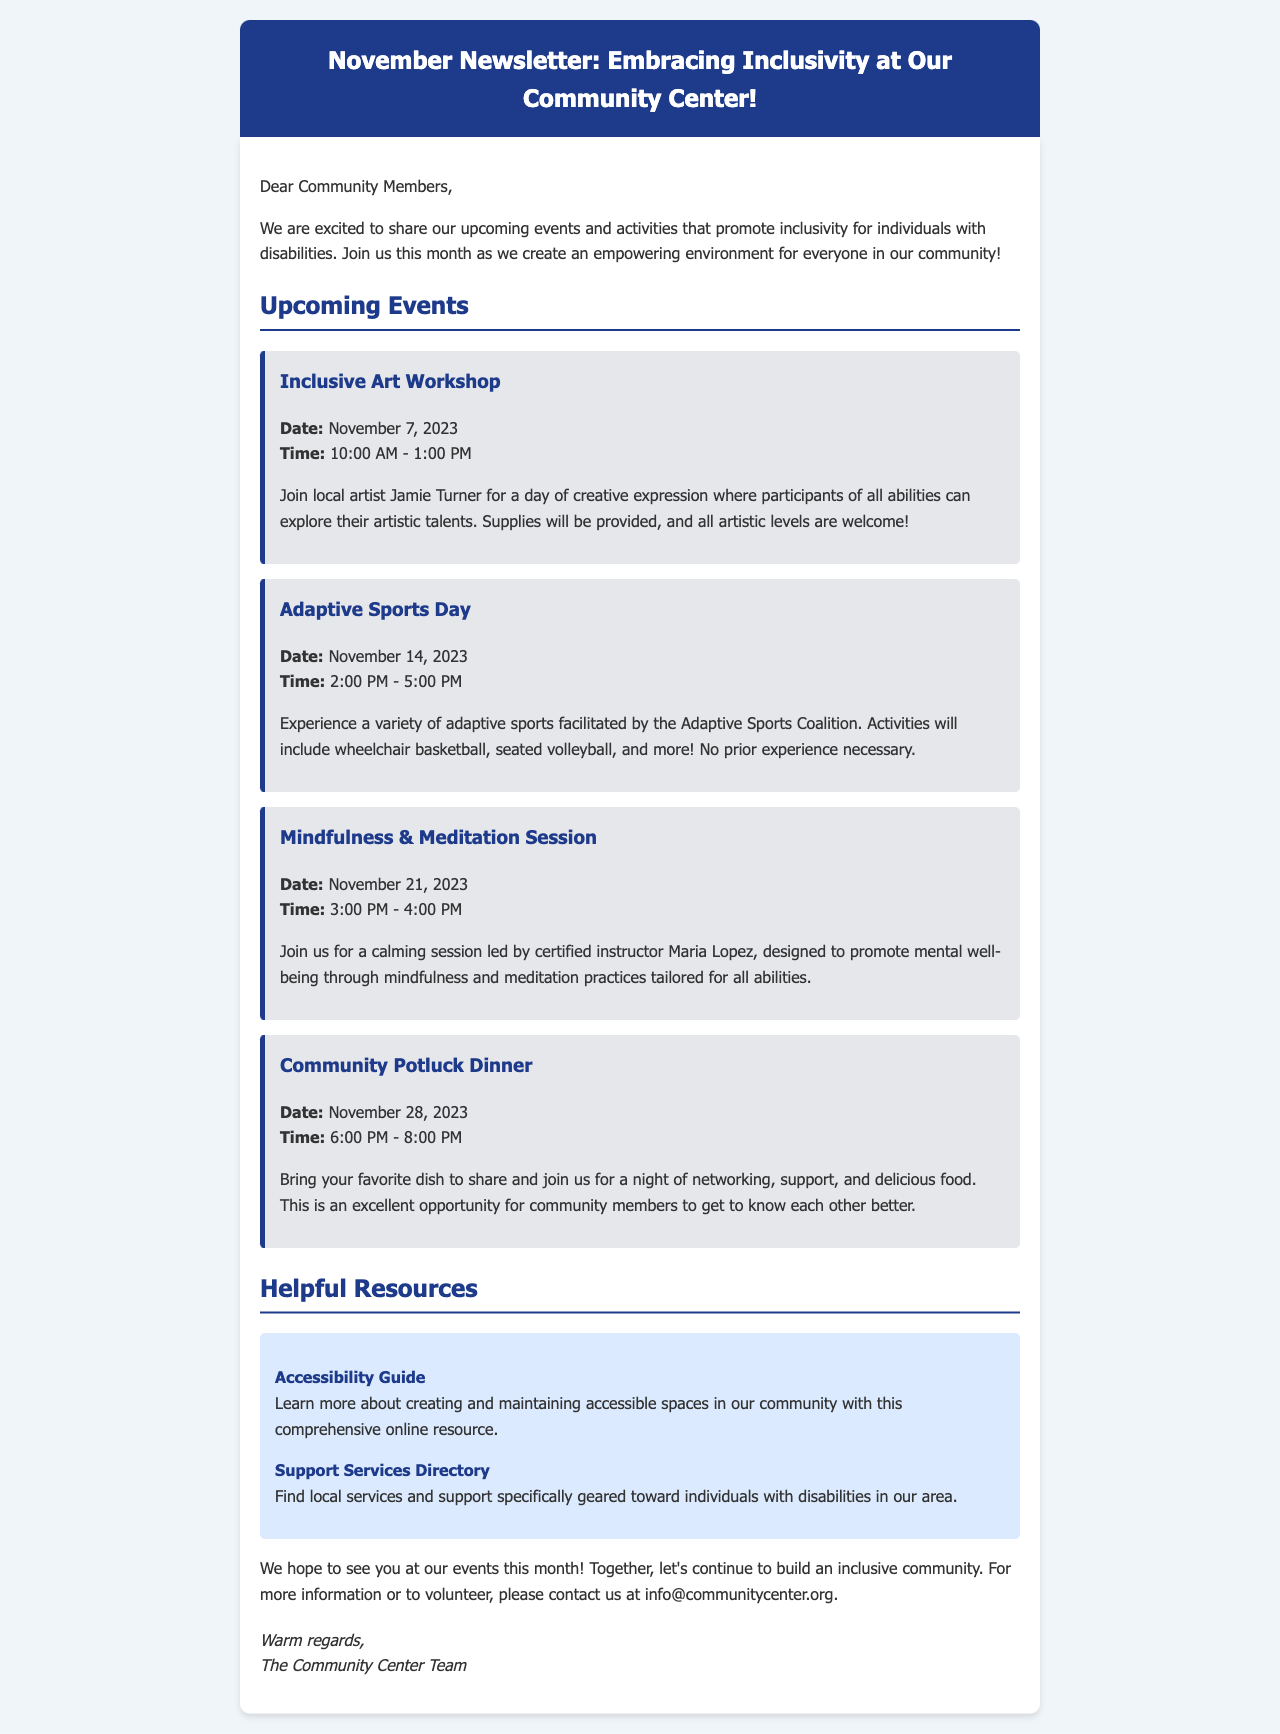What is the title of the newsletter? The title is mentioned at the top of the document in the header section.
Answer: November Newsletter: Embracing Inclusivity at Our Community Center! What is the date of the Inclusive Art Workshop? The date is specified in the details of the event within the content section.
Answer: November 7, 2023 Who is leading the Mindfulness & Meditation Session? The instructor's name is provided in the event description.
Answer: Maria Lopez What time does the Adaptive Sports Day start? The specific time is mentioned in the details of the event.
Answer: 2:00 PM How many upcoming events are listed in the newsletter? Each event is separated within a section in the document, and their count can be determined.
Answer: Four What is included in the Community Potluck Dinner? The document describes what attendees are encouraged to bring to this event.
Answer: Favorite dish What type of resources are mentioned in the newsletter? The document specifically categorizes the information about resources provided.
Answer: Helpful Resources What is the purpose of the Accessibility Guide resource? The description of the resource explains its focus.
Answer: Creating and maintaining accessible spaces What is the main theme of the newsletter? The newsletter introduces events and activities aimed at a specific focus.
Answer: Inclusivity for individuals with disabilities 